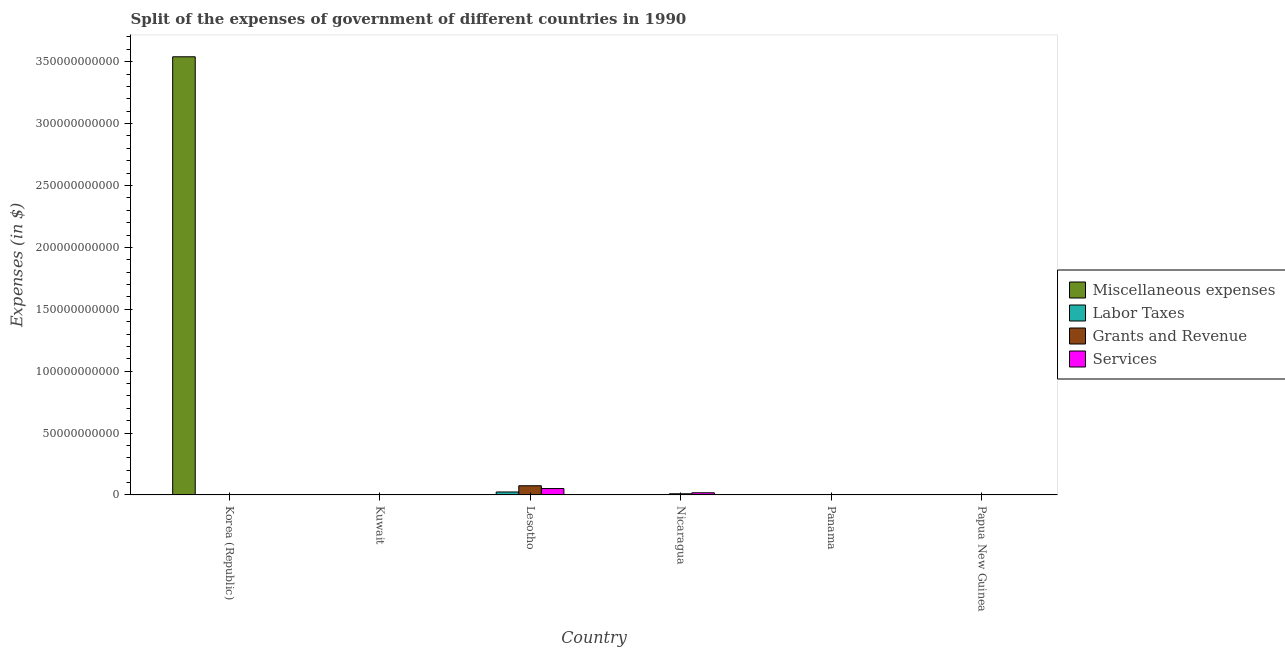How many different coloured bars are there?
Your answer should be compact. 4. How many groups of bars are there?
Your response must be concise. 6. Are the number of bars on each tick of the X-axis equal?
Offer a very short reply. Yes. How many bars are there on the 2nd tick from the left?
Offer a very short reply. 4. How many bars are there on the 2nd tick from the right?
Make the answer very short. 4. What is the label of the 3rd group of bars from the left?
Provide a short and direct response. Lesotho. What is the amount spent on labor taxes in Korea (Republic)?
Offer a terse response. 0.03. Across all countries, what is the maximum amount spent on miscellaneous expenses?
Provide a short and direct response. 3.54e+11. Across all countries, what is the minimum amount spent on miscellaneous expenses?
Your response must be concise. 6.90e+05. What is the total amount spent on miscellaneous expenses in the graph?
Keep it short and to the point. 3.54e+11. What is the difference between the amount spent on services in Lesotho and that in Panama?
Provide a short and direct response. 5.13e+09. What is the difference between the amount spent on labor taxes in Panama and the amount spent on services in Nicaragua?
Provide a succinct answer. -1.74e+09. What is the average amount spent on grants and revenue per country?
Make the answer very short. 1.42e+09. What is the difference between the amount spent on miscellaneous expenses and amount spent on grants and revenue in Kuwait?
Provide a succinct answer. 1.26e+08. What is the ratio of the amount spent on services in Korea (Republic) to that in Lesotho?
Your answer should be compact. 4.0704686289697906e-10. What is the difference between the highest and the second highest amount spent on services?
Your response must be concise. 3.42e+09. What is the difference between the highest and the lowest amount spent on services?
Your answer should be compact. 5.16e+09. Is the sum of the amount spent on grants and revenue in Nicaragua and Papua New Guinea greater than the maximum amount spent on labor taxes across all countries?
Give a very brief answer. No. What does the 3rd bar from the left in Lesotho represents?
Keep it short and to the point. Grants and Revenue. What does the 1st bar from the right in Korea (Republic) represents?
Provide a succinct answer. Services. Is it the case that in every country, the sum of the amount spent on miscellaneous expenses and amount spent on labor taxes is greater than the amount spent on grants and revenue?
Provide a short and direct response. No. Are the values on the major ticks of Y-axis written in scientific E-notation?
Ensure brevity in your answer.  No. Does the graph contain grids?
Give a very brief answer. No. Where does the legend appear in the graph?
Your answer should be very brief. Center right. What is the title of the graph?
Keep it short and to the point. Split of the expenses of government of different countries in 1990. What is the label or title of the X-axis?
Provide a short and direct response. Country. What is the label or title of the Y-axis?
Your answer should be compact. Expenses (in $). What is the Expenses (in $) of Miscellaneous expenses in Korea (Republic)?
Give a very brief answer. 3.54e+11. What is the Expenses (in $) in Labor Taxes in Korea (Republic)?
Keep it short and to the point. 0.03. What is the Expenses (in $) in Grants and Revenue in Korea (Republic)?
Keep it short and to the point. 0.63. What is the Expenses (in $) in Services in Korea (Republic)?
Provide a succinct answer. 2.1. What is the Expenses (in $) in Miscellaneous expenses in Kuwait?
Make the answer very short. 1.56e+08. What is the Expenses (in $) in Labor Taxes in Kuwait?
Provide a succinct answer. 2.10e+07. What is the Expenses (in $) of Grants and Revenue in Kuwait?
Your response must be concise. 3.00e+07. What is the Expenses (in $) in Services in Kuwait?
Ensure brevity in your answer.  4.20e+07. What is the Expenses (in $) of Miscellaneous expenses in Lesotho?
Offer a very short reply. 1.37e+07. What is the Expenses (in $) in Labor Taxes in Lesotho?
Provide a succinct answer. 2.39e+09. What is the Expenses (in $) of Grants and Revenue in Lesotho?
Offer a very short reply. 7.42e+09. What is the Expenses (in $) in Services in Lesotho?
Offer a terse response. 5.16e+09. What is the Expenses (in $) in Miscellaneous expenses in Nicaragua?
Your answer should be compact. 6.90e+05. What is the Expenses (in $) of Labor Taxes in Nicaragua?
Provide a short and direct response. 6.90e+07. What is the Expenses (in $) in Grants and Revenue in Nicaragua?
Make the answer very short. 9.19e+08. What is the Expenses (in $) in Services in Nicaragua?
Keep it short and to the point. 1.75e+09. What is the Expenses (in $) in Miscellaneous expenses in Panama?
Give a very brief answer. 8.40e+06. What is the Expenses (in $) in Labor Taxes in Panama?
Keep it short and to the point. 5.35e+06. What is the Expenses (in $) of Grants and Revenue in Panama?
Provide a short and direct response. 8.85e+07. What is the Expenses (in $) in Services in Panama?
Offer a very short reply. 3.87e+07. What is the Expenses (in $) of Miscellaneous expenses in Papua New Guinea?
Ensure brevity in your answer.  4.37e+06. What is the Expenses (in $) of Labor Taxes in Papua New Guinea?
Your response must be concise. 2.81e+06. What is the Expenses (in $) in Grants and Revenue in Papua New Guinea?
Keep it short and to the point. 9.55e+07. What is the Expenses (in $) of Services in Papua New Guinea?
Offer a terse response. 1.21e+08. Across all countries, what is the maximum Expenses (in $) of Miscellaneous expenses?
Give a very brief answer. 3.54e+11. Across all countries, what is the maximum Expenses (in $) in Labor Taxes?
Ensure brevity in your answer.  2.39e+09. Across all countries, what is the maximum Expenses (in $) of Grants and Revenue?
Make the answer very short. 7.42e+09. Across all countries, what is the maximum Expenses (in $) of Services?
Your response must be concise. 5.16e+09. Across all countries, what is the minimum Expenses (in $) in Miscellaneous expenses?
Provide a short and direct response. 6.90e+05. Across all countries, what is the minimum Expenses (in $) in Labor Taxes?
Provide a succinct answer. 0.03. Across all countries, what is the minimum Expenses (in $) of Grants and Revenue?
Provide a short and direct response. 0.63. Across all countries, what is the minimum Expenses (in $) of Services?
Offer a very short reply. 2.1. What is the total Expenses (in $) of Miscellaneous expenses in the graph?
Give a very brief answer. 3.54e+11. What is the total Expenses (in $) in Labor Taxes in the graph?
Provide a succinct answer. 2.49e+09. What is the total Expenses (in $) in Grants and Revenue in the graph?
Your response must be concise. 8.55e+09. What is the total Expenses (in $) of Services in the graph?
Make the answer very short. 7.11e+09. What is the difference between the Expenses (in $) of Miscellaneous expenses in Korea (Republic) and that in Kuwait?
Your response must be concise. 3.54e+11. What is the difference between the Expenses (in $) of Labor Taxes in Korea (Republic) and that in Kuwait?
Your answer should be very brief. -2.10e+07. What is the difference between the Expenses (in $) in Grants and Revenue in Korea (Republic) and that in Kuwait?
Ensure brevity in your answer.  -3.00e+07. What is the difference between the Expenses (in $) in Services in Korea (Republic) and that in Kuwait?
Offer a very short reply. -4.20e+07. What is the difference between the Expenses (in $) of Miscellaneous expenses in Korea (Republic) and that in Lesotho?
Your answer should be very brief. 3.54e+11. What is the difference between the Expenses (in $) of Labor Taxes in Korea (Republic) and that in Lesotho?
Your answer should be very brief. -2.39e+09. What is the difference between the Expenses (in $) of Grants and Revenue in Korea (Republic) and that in Lesotho?
Your answer should be very brief. -7.42e+09. What is the difference between the Expenses (in $) in Services in Korea (Republic) and that in Lesotho?
Your answer should be very brief. -5.16e+09. What is the difference between the Expenses (in $) of Miscellaneous expenses in Korea (Republic) and that in Nicaragua?
Keep it short and to the point. 3.54e+11. What is the difference between the Expenses (in $) of Labor Taxes in Korea (Republic) and that in Nicaragua?
Your answer should be very brief. -6.90e+07. What is the difference between the Expenses (in $) of Grants and Revenue in Korea (Republic) and that in Nicaragua?
Keep it short and to the point. -9.19e+08. What is the difference between the Expenses (in $) of Services in Korea (Republic) and that in Nicaragua?
Provide a succinct answer. -1.75e+09. What is the difference between the Expenses (in $) in Miscellaneous expenses in Korea (Republic) and that in Panama?
Your response must be concise. 3.54e+11. What is the difference between the Expenses (in $) of Labor Taxes in Korea (Republic) and that in Panama?
Provide a short and direct response. -5.35e+06. What is the difference between the Expenses (in $) of Grants and Revenue in Korea (Republic) and that in Panama?
Give a very brief answer. -8.85e+07. What is the difference between the Expenses (in $) in Services in Korea (Republic) and that in Panama?
Provide a succinct answer. -3.87e+07. What is the difference between the Expenses (in $) of Miscellaneous expenses in Korea (Republic) and that in Papua New Guinea?
Your answer should be compact. 3.54e+11. What is the difference between the Expenses (in $) in Labor Taxes in Korea (Republic) and that in Papua New Guinea?
Provide a short and direct response. -2.81e+06. What is the difference between the Expenses (in $) of Grants and Revenue in Korea (Republic) and that in Papua New Guinea?
Offer a very short reply. -9.55e+07. What is the difference between the Expenses (in $) in Services in Korea (Republic) and that in Papua New Guinea?
Ensure brevity in your answer.  -1.21e+08. What is the difference between the Expenses (in $) of Miscellaneous expenses in Kuwait and that in Lesotho?
Provide a short and direct response. 1.42e+08. What is the difference between the Expenses (in $) in Labor Taxes in Kuwait and that in Lesotho?
Make the answer very short. -2.37e+09. What is the difference between the Expenses (in $) in Grants and Revenue in Kuwait and that in Lesotho?
Ensure brevity in your answer.  -7.39e+09. What is the difference between the Expenses (in $) of Services in Kuwait and that in Lesotho?
Your answer should be compact. -5.12e+09. What is the difference between the Expenses (in $) in Miscellaneous expenses in Kuwait and that in Nicaragua?
Make the answer very short. 1.55e+08. What is the difference between the Expenses (in $) of Labor Taxes in Kuwait and that in Nicaragua?
Make the answer very short. -4.80e+07. What is the difference between the Expenses (in $) in Grants and Revenue in Kuwait and that in Nicaragua?
Your response must be concise. -8.89e+08. What is the difference between the Expenses (in $) of Services in Kuwait and that in Nicaragua?
Provide a succinct answer. -1.70e+09. What is the difference between the Expenses (in $) in Miscellaneous expenses in Kuwait and that in Panama?
Provide a short and direct response. 1.48e+08. What is the difference between the Expenses (in $) in Labor Taxes in Kuwait and that in Panama?
Your response must be concise. 1.56e+07. What is the difference between the Expenses (in $) of Grants and Revenue in Kuwait and that in Panama?
Make the answer very short. -5.85e+07. What is the difference between the Expenses (in $) of Services in Kuwait and that in Panama?
Offer a very short reply. 3.28e+06. What is the difference between the Expenses (in $) of Miscellaneous expenses in Kuwait and that in Papua New Guinea?
Your response must be concise. 1.52e+08. What is the difference between the Expenses (in $) of Labor Taxes in Kuwait and that in Papua New Guinea?
Offer a very short reply. 1.82e+07. What is the difference between the Expenses (in $) in Grants and Revenue in Kuwait and that in Papua New Guinea?
Make the answer very short. -6.55e+07. What is the difference between the Expenses (in $) in Services in Kuwait and that in Papua New Guinea?
Give a very brief answer. -7.94e+07. What is the difference between the Expenses (in $) in Miscellaneous expenses in Lesotho and that in Nicaragua?
Ensure brevity in your answer.  1.30e+07. What is the difference between the Expenses (in $) of Labor Taxes in Lesotho and that in Nicaragua?
Provide a succinct answer. 2.32e+09. What is the difference between the Expenses (in $) in Grants and Revenue in Lesotho and that in Nicaragua?
Your answer should be compact. 6.50e+09. What is the difference between the Expenses (in $) of Services in Lesotho and that in Nicaragua?
Offer a very short reply. 3.42e+09. What is the difference between the Expenses (in $) in Miscellaneous expenses in Lesotho and that in Panama?
Your answer should be compact. 5.30e+06. What is the difference between the Expenses (in $) in Labor Taxes in Lesotho and that in Panama?
Make the answer very short. 2.39e+09. What is the difference between the Expenses (in $) of Grants and Revenue in Lesotho and that in Panama?
Make the answer very short. 7.33e+09. What is the difference between the Expenses (in $) in Services in Lesotho and that in Panama?
Provide a succinct answer. 5.13e+09. What is the difference between the Expenses (in $) in Miscellaneous expenses in Lesotho and that in Papua New Guinea?
Provide a succinct answer. 9.33e+06. What is the difference between the Expenses (in $) of Labor Taxes in Lesotho and that in Papua New Guinea?
Your answer should be compact. 2.39e+09. What is the difference between the Expenses (in $) of Grants and Revenue in Lesotho and that in Papua New Guinea?
Provide a succinct answer. 7.32e+09. What is the difference between the Expenses (in $) of Services in Lesotho and that in Papua New Guinea?
Give a very brief answer. 5.04e+09. What is the difference between the Expenses (in $) in Miscellaneous expenses in Nicaragua and that in Panama?
Ensure brevity in your answer.  -7.71e+06. What is the difference between the Expenses (in $) in Labor Taxes in Nicaragua and that in Panama?
Give a very brief answer. 6.36e+07. What is the difference between the Expenses (in $) in Grants and Revenue in Nicaragua and that in Panama?
Your answer should be very brief. 8.31e+08. What is the difference between the Expenses (in $) of Services in Nicaragua and that in Panama?
Give a very brief answer. 1.71e+09. What is the difference between the Expenses (in $) of Miscellaneous expenses in Nicaragua and that in Papua New Guinea?
Offer a very short reply. -3.68e+06. What is the difference between the Expenses (in $) in Labor Taxes in Nicaragua and that in Papua New Guinea?
Offer a very short reply. 6.62e+07. What is the difference between the Expenses (in $) of Grants and Revenue in Nicaragua and that in Papua New Guinea?
Your response must be concise. 8.24e+08. What is the difference between the Expenses (in $) in Services in Nicaragua and that in Papua New Guinea?
Keep it short and to the point. 1.63e+09. What is the difference between the Expenses (in $) of Miscellaneous expenses in Panama and that in Papua New Guinea?
Provide a short and direct response. 4.03e+06. What is the difference between the Expenses (in $) of Labor Taxes in Panama and that in Papua New Guinea?
Your answer should be very brief. 2.54e+06. What is the difference between the Expenses (in $) of Grants and Revenue in Panama and that in Papua New Guinea?
Keep it short and to the point. -7.03e+06. What is the difference between the Expenses (in $) in Services in Panama and that in Papua New Guinea?
Provide a succinct answer. -8.27e+07. What is the difference between the Expenses (in $) of Miscellaneous expenses in Korea (Republic) and the Expenses (in $) of Labor Taxes in Kuwait?
Your response must be concise. 3.54e+11. What is the difference between the Expenses (in $) of Miscellaneous expenses in Korea (Republic) and the Expenses (in $) of Grants and Revenue in Kuwait?
Provide a succinct answer. 3.54e+11. What is the difference between the Expenses (in $) in Miscellaneous expenses in Korea (Republic) and the Expenses (in $) in Services in Kuwait?
Offer a very short reply. 3.54e+11. What is the difference between the Expenses (in $) of Labor Taxes in Korea (Republic) and the Expenses (in $) of Grants and Revenue in Kuwait?
Provide a succinct answer. -3.00e+07. What is the difference between the Expenses (in $) of Labor Taxes in Korea (Republic) and the Expenses (in $) of Services in Kuwait?
Your response must be concise. -4.20e+07. What is the difference between the Expenses (in $) of Grants and Revenue in Korea (Republic) and the Expenses (in $) of Services in Kuwait?
Your response must be concise. -4.20e+07. What is the difference between the Expenses (in $) of Miscellaneous expenses in Korea (Republic) and the Expenses (in $) of Labor Taxes in Lesotho?
Your response must be concise. 3.52e+11. What is the difference between the Expenses (in $) of Miscellaneous expenses in Korea (Republic) and the Expenses (in $) of Grants and Revenue in Lesotho?
Keep it short and to the point. 3.47e+11. What is the difference between the Expenses (in $) in Miscellaneous expenses in Korea (Republic) and the Expenses (in $) in Services in Lesotho?
Offer a terse response. 3.49e+11. What is the difference between the Expenses (in $) of Labor Taxes in Korea (Republic) and the Expenses (in $) of Grants and Revenue in Lesotho?
Your response must be concise. -7.42e+09. What is the difference between the Expenses (in $) of Labor Taxes in Korea (Republic) and the Expenses (in $) of Services in Lesotho?
Offer a terse response. -5.16e+09. What is the difference between the Expenses (in $) of Grants and Revenue in Korea (Republic) and the Expenses (in $) of Services in Lesotho?
Keep it short and to the point. -5.16e+09. What is the difference between the Expenses (in $) in Miscellaneous expenses in Korea (Republic) and the Expenses (in $) in Labor Taxes in Nicaragua?
Your response must be concise. 3.54e+11. What is the difference between the Expenses (in $) of Miscellaneous expenses in Korea (Republic) and the Expenses (in $) of Grants and Revenue in Nicaragua?
Your response must be concise. 3.53e+11. What is the difference between the Expenses (in $) of Miscellaneous expenses in Korea (Republic) and the Expenses (in $) of Services in Nicaragua?
Your answer should be compact. 3.52e+11. What is the difference between the Expenses (in $) of Labor Taxes in Korea (Republic) and the Expenses (in $) of Grants and Revenue in Nicaragua?
Give a very brief answer. -9.19e+08. What is the difference between the Expenses (in $) of Labor Taxes in Korea (Republic) and the Expenses (in $) of Services in Nicaragua?
Provide a succinct answer. -1.75e+09. What is the difference between the Expenses (in $) in Grants and Revenue in Korea (Republic) and the Expenses (in $) in Services in Nicaragua?
Provide a short and direct response. -1.75e+09. What is the difference between the Expenses (in $) in Miscellaneous expenses in Korea (Republic) and the Expenses (in $) in Labor Taxes in Panama?
Your answer should be compact. 3.54e+11. What is the difference between the Expenses (in $) of Miscellaneous expenses in Korea (Republic) and the Expenses (in $) of Grants and Revenue in Panama?
Your answer should be compact. 3.54e+11. What is the difference between the Expenses (in $) in Miscellaneous expenses in Korea (Republic) and the Expenses (in $) in Services in Panama?
Offer a very short reply. 3.54e+11. What is the difference between the Expenses (in $) in Labor Taxes in Korea (Republic) and the Expenses (in $) in Grants and Revenue in Panama?
Your response must be concise. -8.85e+07. What is the difference between the Expenses (in $) in Labor Taxes in Korea (Republic) and the Expenses (in $) in Services in Panama?
Ensure brevity in your answer.  -3.87e+07. What is the difference between the Expenses (in $) of Grants and Revenue in Korea (Republic) and the Expenses (in $) of Services in Panama?
Your response must be concise. -3.87e+07. What is the difference between the Expenses (in $) of Miscellaneous expenses in Korea (Republic) and the Expenses (in $) of Labor Taxes in Papua New Guinea?
Your answer should be compact. 3.54e+11. What is the difference between the Expenses (in $) of Miscellaneous expenses in Korea (Republic) and the Expenses (in $) of Grants and Revenue in Papua New Guinea?
Make the answer very short. 3.54e+11. What is the difference between the Expenses (in $) of Miscellaneous expenses in Korea (Republic) and the Expenses (in $) of Services in Papua New Guinea?
Ensure brevity in your answer.  3.54e+11. What is the difference between the Expenses (in $) in Labor Taxes in Korea (Republic) and the Expenses (in $) in Grants and Revenue in Papua New Guinea?
Offer a terse response. -9.55e+07. What is the difference between the Expenses (in $) in Labor Taxes in Korea (Republic) and the Expenses (in $) in Services in Papua New Guinea?
Offer a terse response. -1.21e+08. What is the difference between the Expenses (in $) in Grants and Revenue in Korea (Republic) and the Expenses (in $) in Services in Papua New Guinea?
Ensure brevity in your answer.  -1.21e+08. What is the difference between the Expenses (in $) in Miscellaneous expenses in Kuwait and the Expenses (in $) in Labor Taxes in Lesotho?
Your answer should be very brief. -2.24e+09. What is the difference between the Expenses (in $) in Miscellaneous expenses in Kuwait and the Expenses (in $) in Grants and Revenue in Lesotho?
Your answer should be compact. -7.26e+09. What is the difference between the Expenses (in $) in Miscellaneous expenses in Kuwait and the Expenses (in $) in Services in Lesotho?
Your answer should be very brief. -5.01e+09. What is the difference between the Expenses (in $) of Labor Taxes in Kuwait and the Expenses (in $) of Grants and Revenue in Lesotho?
Your answer should be compact. -7.40e+09. What is the difference between the Expenses (in $) in Labor Taxes in Kuwait and the Expenses (in $) in Services in Lesotho?
Offer a terse response. -5.14e+09. What is the difference between the Expenses (in $) of Grants and Revenue in Kuwait and the Expenses (in $) of Services in Lesotho?
Your answer should be very brief. -5.13e+09. What is the difference between the Expenses (in $) of Miscellaneous expenses in Kuwait and the Expenses (in $) of Labor Taxes in Nicaragua?
Ensure brevity in your answer.  8.70e+07. What is the difference between the Expenses (in $) of Miscellaneous expenses in Kuwait and the Expenses (in $) of Grants and Revenue in Nicaragua?
Provide a succinct answer. -7.63e+08. What is the difference between the Expenses (in $) in Miscellaneous expenses in Kuwait and the Expenses (in $) in Services in Nicaragua?
Offer a very short reply. -1.59e+09. What is the difference between the Expenses (in $) of Labor Taxes in Kuwait and the Expenses (in $) of Grants and Revenue in Nicaragua?
Your response must be concise. -8.98e+08. What is the difference between the Expenses (in $) of Labor Taxes in Kuwait and the Expenses (in $) of Services in Nicaragua?
Offer a terse response. -1.73e+09. What is the difference between the Expenses (in $) in Grants and Revenue in Kuwait and the Expenses (in $) in Services in Nicaragua?
Your answer should be compact. -1.72e+09. What is the difference between the Expenses (in $) of Miscellaneous expenses in Kuwait and the Expenses (in $) of Labor Taxes in Panama?
Offer a very short reply. 1.51e+08. What is the difference between the Expenses (in $) in Miscellaneous expenses in Kuwait and the Expenses (in $) in Grants and Revenue in Panama?
Provide a short and direct response. 6.75e+07. What is the difference between the Expenses (in $) of Miscellaneous expenses in Kuwait and the Expenses (in $) of Services in Panama?
Your answer should be very brief. 1.17e+08. What is the difference between the Expenses (in $) of Labor Taxes in Kuwait and the Expenses (in $) of Grants and Revenue in Panama?
Make the answer very short. -6.75e+07. What is the difference between the Expenses (in $) in Labor Taxes in Kuwait and the Expenses (in $) in Services in Panama?
Your answer should be very brief. -1.77e+07. What is the difference between the Expenses (in $) in Grants and Revenue in Kuwait and the Expenses (in $) in Services in Panama?
Keep it short and to the point. -8.72e+06. What is the difference between the Expenses (in $) in Miscellaneous expenses in Kuwait and the Expenses (in $) in Labor Taxes in Papua New Guinea?
Provide a short and direct response. 1.53e+08. What is the difference between the Expenses (in $) of Miscellaneous expenses in Kuwait and the Expenses (in $) of Grants and Revenue in Papua New Guinea?
Keep it short and to the point. 6.05e+07. What is the difference between the Expenses (in $) in Miscellaneous expenses in Kuwait and the Expenses (in $) in Services in Papua New Guinea?
Your response must be concise. 3.46e+07. What is the difference between the Expenses (in $) in Labor Taxes in Kuwait and the Expenses (in $) in Grants and Revenue in Papua New Guinea?
Keep it short and to the point. -7.45e+07. What is the difference between the Expenses (in $) of Labor Taxes in Kuwait and the Expenses (in $) of Services in Papua New Guinea?
Offer a terse response. -1.00e+08. What is the difference between the Expenses (in $) in Grants and Revenue in Kuwait and the Expenses (in $) in Services in Papua New Guinea?
Provide a succinct answer. -9.14e+07. What is the difference between the Expenses (in $) in Miscellaneous expenses in Lesotho and the Expenses (in $) in Labor Taxes in Nicaragua?
Provide a succinct answer. -5.53e+07. What is the difference between the Expenses (in $) in Miscellaneous expenses in Lesotho and the Expenses (in $) in Grants and Revenue in Nicaragua?
Make the answer very short. -9.06e+08. What is the difference between the Expenses (in $) of Miscellaneous expenses in Lesotho and the Expenses (in $) of Services in Nicaragua?
Make the answer very short. -1.73e+09. What is the difference between the Expenses (in $) in Labor Taxes in Lesotho and the Expenses (in $) in Grants and Revenue in Nicaragua?
Your response must be concise. 1.47e+09. What is the difference between the Expenses (in $) in Labor Taxes in Lesotho and the Expenses (in $) in Services in Nicaragua?
Offer a terse response. 6.44e+08. What is the difference between the Expenses (in $) of Grants and Revenue in Lesotho and the Expenses (in $) of Services in Nicaragua?
Offer a terse response. 5.67e+09. What is the difference between the Expenses (in $) in Miscellaneous expenses in Lesotho and the Expenses (in $) in Labor Taxes in Panama?
Offer a terse response. 8.35e+06. What is the difference between the Expenses (in $) of Miscellaneous expenses in Lesotho and the Expenses (in $) of Grants and Revenue in Panama?
Your response must be concise. -7.48e+07. What is the difference between the Expenses (in $) of Miscellaneous expenses in Lesotho and the Expenses (in $) of Services in Panama?
Your answer should be very brief. -2.50e+07. What is the difference between the Expenses (in $) in Labor Taxes in Lesotho and the Expenses (in $) in Grants and Revenue in Panama?
Give a very brief answer. 2.30e+09. What is the difference between the Expenses (in $) in Labor Taxes in Lesotho and the Expenses (in $) in Services in Panama?
Give a very brief answer. 2.35e+09. What is the difference between the Expenses (in $) in Grants and Revenue in Lesotho and the Expenses (in $) in Services in Panama?
Your answer should be compact. 7.38e+09. What is the difference between the Expenses (in $) in Miscellaneous expenses in Lesotho and the Expenses (in $) in Labor Taxes in Papua New Guinea?
Make the answer very short. 1.09e+07. What is the difference between the Expenses (in $) of Miscellaneous expenses in Lesotho and the Expenses (in $) of Grants and Revenue in Papua New Guinea?
Offer a terse response. -8.18e+07. What is the difference between the Expenses (in $) in Miscellaneous expenses in Lesotho and the Expenses (in $) in Services in Papua New Guinea?
Your response must be concise. -1.08e+08. What is the difference between the Expenses (in $) of Labor Taxes in Lesotho and the Expenses (in $) of Grants and Revenue in Papua New Guinea?
Make the answer very short. 2.30e+09. What is the difference between the Expenses (in $) in Labor Taxes in Lesotho and the Expenses (in $) in Services in Papua New Guinea?
Provide a succinct answer. 2.27e+09. What is the difference between the Expenses (in $) of Grants and Revenue in Lesotho and the Expenses (in $) of Services in Papua New Guinea?
Provide a short and direct response. 7.29e+09. What is the difference between the Expenses (in $) of Miscellaneous expenses in Nicaragua and the Expenses (in $) of Labor Taxes in Panama?
Your answer should be compact. -4.66e+06. What is the difference between the Expenses (in $) in Miscellaneous expenses in Nicaragua and the Expenses (in $) in Grants and Revenue in Panama?
Offer a very short reply. -8.78e+07. What is the difference between the Expenses (in $) of Miscellaneous expenses in Nicaragua and the Expenses (in $) of Services in Panama?
Your answer should be very brief. -3.80e+07. What is the difference between the Expenses (in $) in Labor Taxes in Nicaragua and the Expenses (in $) in Grants and Revenue in Panama?
Your response must be concise. -1.95e+07. What is the difference between the Expenses (in $) in Labor Taxes in Nicaragua and the Expenses (in $) in Services in Panama?
Keep it short and to the point. 3.03e+07. What is the difference between the Expenses (in $) in Grants and Revenue in Nicaragua and the Expenses (in $) in Services in Panama?
Ensure brevity in your answer.  8.81e+08. What is the difference between the Expenses (in $) in Miscellaneous expenses in Nicaragua and the Expenses (in $) in Labor Taxes in Papua New Guinea?
Keep it short and to the point. -2.12e+06. What is the difference between the Expenses (in $) in Miscellaneous expenses in Nicaragua and the Expenses (in $) in Grants and Revenue in Papua New Guinea?
Your answer should be very brief. -9.48e+07. What is the difference between the Expenses (in $) in Miscellaneous expenses in Nicaragua and the Expenses (in $) in Services in Papua New Guinea?
Your answer should be compact. -1.21e+08. What is the difference between the Expenses (in $) of Labor Taxes in Nicaragua and the Expenses (in $) of Grants and Revenue in Papua New Guinea?
Ensure brevity in your answer.  -2.65e+07. What is the difference between the Expenses (in $) in Labor Taxes in Nicaragua and the Expenses (in $) in Services in Papua New Guinea?
Provide a short and direct response. -5.24e+07. What is the difference between the Expenses (in $) in Grants and Revenue in Nicaragua and the Expenses (in $) in Services in Papua New Guinea?
Ensure brevity in your answer.  7.98e+08. What is the difference between the Expenses (in $) of Miscellaneous expenses in Panama and the Expenses (in $) of Labor Taxes in Papua New Guinea?
Keep it short and to the point. 5.59e+06. What is the difference between the Expenses (in $) in Miscellaneous expenses in Panama and the Expenses (in $) in Grants and Revenue in Papua New Guinea?
Give a very brief answer. -8.71e+07. What is the difference between the Expenses (in $) in Miscellaneous expenses in Panama and the Expenses (in $) in Services in Papua New Guinea?
Your response must be concise. -1.13e+08. What is the difference between the Expenses (in $) in Labor Taxes in Panama and the Expenses (in $) in Grants and Revenue in Papua New Guinea?
Your response must be concise. -9.02e+07. What is the difference between the Expenses (in $) of Labor Taxes in Panama and the Expenses (in $) of Services in Papua New Guinea?
Make the answer very short. -1.16e+08. What is the difference between the Expenses (in $) of Grants and Revenue in Panama and the Expenses (in $) of Services in Papua New Guinea?
Offer a terse response. -3.29e+07. What is the average Expenses (in $) of Miscellaneous expenses per country?
Provide a short and direct response. 5.90e+1. What is the average Expenses (in $) in Labor Taxes per country?
Offer a very short reply. 4.15e+08. What is the average Expenses (in $) in Grants and Revenue per country?
Give a very brief answer. 1.42e+09. What is the average Expenses (in $) of Services per country?
Make the answer very short. 1.19e+09. What is the difference between the Expenses (in $) of Miscellaneous expenses and Expenses (in $) of Labor Taxes in Korea (Republic)?
Offer a very short reply. 3.54e+11. What is the difference between the Expenses (in $) of Miscellaneous expenses and Expenses (in $) of Grants and Revenue in Korea (Republic)?
Ensure brevity in your answer.  3.54e+11. What is the difference between the Expenses (in $) of Miscellaneous expenses and Expenses (in $) of Services in Korea (Republic)?
Your answer should be compact. 3.54e+11. What is the difference between the Expenses (in $) of Labor Taxes and Expenses (in $) of Grants and Revenue in Korea (Republic)?
Your answer should be compact. -0.6. What is the difference between the Expenses (in $) in Labor Taxes and Expenses (in $) in Services in Korea (Republic)?
Offer a terse response. -2.07. What is the difference between the Expenses (in $) in Grants and Revenue and Expenses (in $) in Services in Korea (Republic)?
Your answer should be compact. -1.47. What is the difference between the Expenses (in $) of Miscellaneous expenses and Expenses (in $) of Labor Taxes in Kuwait?
Provide a succinct answer. 1.35e+08. What is the difference between the Expenses (in $) of Miscellaneous expenses and Expenses (in $) of Grants and Revenue in Kuwait?
Your answer should be compact. 1.26e+08. What is the difference between the Expenses (in $) of Miscellaneous expenses and Expenses (in $) of Services in Kuwait?
Provide a succinct answer. 1.14e+08. What is the difference between the Expenses (in $) of Labor Taxes and Expenses (in $) of Grants and Revenue in Kuwait?
Make the answer very short. -9.00e+06. What is the difference between the Expenses (in $) of Labor Taxes and Expenses (in $) of Services in Kuwait?
Your answer should be compact. -2.10e+07. What is the difference between the Expenses (in $) of Grants and Revenue and Expenses (in $) of Services in Kuwait?
Your response must be concise. -1.20e+07. What is the difference between the Expenses (in $) in Miscellaneous expenses and Expenses (in $) in Labor Taxes in Lesotho?
Your answer should be compact. -2.38e+09. What is the difference between the Expenses (in $) in Miscellaneous expenses and Expenses (in $) in Grants and Revenue in Lesotho?
Provide a short and direct response. -7.40e+09. What is the difference between the Expenses (in $) of Miscellaneous expenses and Expenses (in $) of Services in Lesotho?
Keep it short and to the point. -5.15e+09. What is the difference between the Expenses (in $) of Labor Taxes and Expenses (in $) of Grants and Revenue in Lesotho?
Your answer should be very brief. -5.02e+09. What is the difference between the Expenses (in $) in Labor Taxes and Expenses (in $) in Services in Lesotho?
Make the answer very short. -2.77e+09. What is the difference between the Expenses (in $) of Grants and Revenue and Expenses (in $) of Services in Lesotho?
Your answer should be very brief. 2.25e+09. What is the difference between the Expenses (in $) of Miscellaneous expenses and Expenses (in $) of Labor Taxes in Nicaragua?
Give a very brief answer. -6.83e+07. What is the difference between the Expenses (in $) of Miscellaneous expenses and Expenses (in $) of Grants and Revenue in Nicaragua?
Your answer should be compact. -9.19e+08. What is the difference between the Expenses (in $) in Miscellaneous expenses and Expenses (in $) in Services in Nicaragua?
Your answer should be compact. -1.75e+09. What is the difference between the Expenses (in $) in Labor Taxes and Expenses (in $) in Grants and Revenue in Nicaragua?
Provide a succinct answer. -8.50e+08. What is the difference between the Expenses (in $) of Labor Taxes and Expenses (in $) of Services in Nicaragua?
Ensure brevity in your answer.  -1.68e+09. What is the difference between the Expenses (in $) in Grants and Revenue and Expenses (in $) in Services in Nicaragua?
Your answer should be very brief. -8.27e+08. What is the difference between the Expenses (in $) of Miscellaneous expenses and Expenses (in $) of Labor Taxes in Panama?
Offer a very short reply. 3.05e+06. What is the difference between the Expenses (in $) of Miscellaneous expenses and Expenses (in $) of Grants and Revenue in Panama?
Make the answer very short. -8.01e+07. What is the difference between the Expenses (in $) of Miscellaneous expenses and Expenses (in $) of Services in Panama?
Provide a short and direct response. -3.03e+07. What is the difference between the Expenses (in $) of Labor Taxes and Expenses (in $) of Grants and Revenue in Panama?
Offer a very short reply. -8.31e+07. What is the difference between the Expenses (in $) in Labor Taxes and Expenses (in $) in Services in Panama?
Your answer should be compact. -3.34e+07. What is the difference between the Expenses (in $) of Grants and Revenue and Expenses (in $) of Services in Panama?
Make the answer very short. 4.98e+07. What is the difference between the Expenses (in $) in Miscellaneous expenses and Expenses (in $) in Labor Taxes in Papua New Guinea?
Provide a succinct answer. 1.56e+06. What is the difference between the Expenses (in $) of Miscellaneous expenses and Expenses (in $) of Grants and Revenue in Papua New Guinea?
Your answer should be compact. -9.11e+07. What is the difference between the Expenses (in $) of Miscellaneous expenses and Expenses (in $) of Services in Papua New Guinea?
Your answer should be very brief. -1.17e+08. What is the difference between the Expenses (in $) of Labor Taxes and Expenses (in $) of Grants and Revenue in Papua New Guinea?
Give a very brief answer. -9.27e+07. What is the difference between the Expenses (in $) in Labor Taxes and Expenses (in $) in Services in Papua New Guinea?
Provide a short and direct response. -1.19e+08. What is the difference between the Expenses (in $) of Grants and Revenue and Expenses (in $) of Services in Papua New Guinea?
Your answer should be compact. -2.59e+07. What is the ratio of the Expenses (in $) of Miscellaneous expenses in Korea (Republic) to that in Kuwait?
Your answer should be compact. 2269.23. What is the ratio of the Expenses (in $) of Grants and Revenue in Korea (Republic) to that in Kuwait?
Offer a terse response. 0. What is the ratio of the Expenses (in $) of Services in Korea (Republic) to that in Kuwait?
Offer a terse response. 0. What is the ratio of the Expenses (in $) of Miscellaneous expenses in Korea (Republic) to that in Lesotho?
Your answer should be compact. 2.58e+04. What is the ratio of the Expenses (in $) in Labor Taxes in Korea (Republic) to that in Lesotho?
Your response must be concise. 0. What is the ratio of the Expenses (in $) in Miscellaneous expenses in Korea (Republic) to that in Nicaragua?
Make the answer very short. 5.13e+05. What is the ratio of the Expenses (in $) in Services in Korea (Republic) to that in Nicaragua?
Offer a very short reply. 0. What is the ratio of the Expenses (in $) in Miscellaneous expenses in Korea (Republic) to that in Panama?
Make the answer very short. 4.21e+04. What is the ratio of the Expenses (in $) of Grants and Revenue in Korea (Republic) to that in Panama?
Ensure brevity in your answer.  0. What is the ratio of the Expenses (in $) in Services in Korea (Republic) to that in Panama?
Ensure brevity in your answer.  0. What is the ratio of the Expenses (in $) in Miscellaneous expenses in Korea (Republic) to that in Papua New Guinea?
Keep it short and to the point. 8.10e+04. What is the ratio of the Expenses (in $) of Labor Taxes in Korea (Republic) to that in Papua New Guinea?
Offer a terse response. 0. What is the ratio of the Expenses (in $) of Grants and Revenue in Korea (Republic) to that in Papua New Guinea?
Ensure brevity in your answer.  0. What is the ratio of the Expenses (in $) in Miscellaneous expenses in Kuwait to that in Lesotho?
Your answer should be very brief. 11.39. What is the ratio of the Expenses (in $) of Labor Taxes in Kuwait to that in Lesotho?
Provide a succinct answer. 0.01. What is the ratio of the Expenses (in $) in Grants and Revenue in Kuwait to that in Lesotho?
Your answer should be compact. 0. What is the ratio of the Expenses (in $) of Services in Kuwait to that in Lesotho?
Ensure brevity in your answer.  0.01. What is the ratio of the Expenses (in $) of Miscellaneous expenses in Kuwait to that in Nicaragua?
Provide a succinct answer. 226.09. What is the ratio of the Expenses (in $) in Labor Taxes in Kuwait to that in Nicaragua?
Provide a short and direct response. 0.3. What is the ratio of the Expenses (in $) in Grants and Revenue in Kuwait to that in Nicaragua?
Ensure brevity in your answer.  0.03. What is the ratio of the Expenses (in $) of Services in Kuwait to that in Nicaragua?
Keep it short and to the point. 0.02. What is the ratio of the Expenses (in $) of Miscellaneous expenses in Kuwait to that in Panama?
Keep it short and to the point. 18.57. What is the ratio of the Expenses (in $) in Labor Taxes in Kuwait to that in Panama?
Keep it short and to the point. 3.93. What is the ratio of the Expenses (in $) of Grants and Revenue in Kuwait to that in Panama?
Provide a succinct answer. 0.34. What is the ratio of the Expenses (in $) of Services in Kuwait to that in Panama?
Your answer should be compact. 1.08. What is the ratio of the Expenses (in $) of Miscellaneous expenses in Kuwait to that in Papua New Guinea?
Provide a short and direct response. 35.7. What is the ratio of the Expenses (in $) in Labor Taxes in Kuwait to that in Papua New Guinea?
Your answer should be compact. 7.47. What is the ratio of the Expenses (in $) in Grants and Revenue in Kuwait to that in Papua New Guinea?
Provide a short and direct response. 0.31. What is the ratio of the Expenses (in $) in Services in Kuwait to that in Papua New Guinea?
Make the answer very short. 0.35. What is the ratio of the Expenses (in $) in Miscellaneous expenses in Lesotho to that in Nicaragua?
Provide a short and direct response. 19.86. What is the ratio of the Expenses (in $) of Labor Taxes in Lesotho to that in Nicaragua?
Provide a short and direct response. 34.65. What is the ratio of the Expenses (in $) in Grants and Revenue in Lesotho to that in Nicaragua?
Give a very brief answer. 8.07. What is the ratio of the Expenses (in $) in Services in Lesotho to that in Nicaragua?
Provide a succinct answer. 2.96. What is the ratio of the Expenses (in $) in Miscellaneous expenses in Lesotho to that in Panama?
Your response must be concise. 1.63. What is the ratio of the Expenses (in $) in Labor Taxes in Lesotho to that in Panama?
Make the answer very short. 446.92. What is the ratio of the Expenses (in $) in Grants and Revenue in Lesotho to that in Panama?
Make the answer very short. 83.83. What is the ratio of the Expenses (in $) of Services in Lesotho to that in Panama?
Offer a very short reply. 133.37. What is the ratio of the Expenses (in $) of Miscellaneous expenses in Lesotho to that in Papua New Guinea?
Your response must be concise. 3.13. What is the ratio of the Expenses (in $) of Labor Taxes in Lesotho to that in Papua New Guinea?
Keep it short and to the point. 850.89. What is the ratio of the Expenses (in $) in Grants and Revenue in Lesotho to that in Papua New Guinea?
Keep it short and to the point. 77.65. What is the ratio of the Expenses (in $) in Services in Lesotho to that in Papua New Guinea?
Your response must be concise. 42.53. What is the ratio of the Expenses (in $) in Miscellaneous expenses in Nicaragua to that in Panama?
Keep it short and to the point. 0.08. What is the ratio of the Expenses (in $) in Labor Taxes in Nicaragua to that in Panama?
Ensure brevity in your answer.  12.9. What is the ratio of the Expenses (in $) of Grants and Revenue in Nicaragua to that in Panama?
Give a very brief answer. 10.39. What is the ratio of the Expenses (in $) in Services in Nicaragua to that in Panama?
Offer a terse response. 45.11. What is the ratio of the Expenses (in $) of Miscellaneous expenses in Nicaragua to that in Papua New Guinea?
Provide a succinct answer. 0.16. What is the ratio of the Expenses (in $) of Labor Taxes in Nicaragua to that in Papua New Guinea?
Offer a very short reply. 24.56. What is the ratio of the Expenses (in $) of Grants and Revenue in Nicaragua to that in Papua New Guinea?
Provide a short and direct response. 9.63. What is the ratio of the Expenses (in $) of Services in Nicaragua to that in Papua New Guinea?
Make the answer very short. 14.39. What is the ratio of the Expenses (in $) in Miscellaneous expenses in Panama to that in Papua New Guinea?
Make the answer very short. 1.92. What is the ratio of the Expenses (in $) of Labor Taxes in Panama to that in Papua New Guinea?
Make the answer very short. 1.9. What is the ratio of the Expenses (in $) of Grants and Revenue in Panama to that in Papua New Guinea?
Your response must be concise. 0.93. What is the ratio of the Expenses (in $) of Services in Panama to that in Papua New Guinea?
Provide a succinct answer. 0.32. What is the difference between the highest and the second highest Expenses (in $) of Miscellaneous expenses?
Offer a terse response. 3.54e+11. What is the difference between the highest and the second highest Expenses (in $) in Labor Taxes?
Your answer should be very brief. 2.32e+09. What is the difference between the highest and the second highest Expenses (in $) in Grants and Revenue?
Provide a short and direct response. 6.50e+09. What is the difference between the highest and the second highest Expenses (in $) in Services?
Keep it short and to the point. 3.42e+09. What is the difference between the highest and the lowest Expenses (in $) in Miscellaneous expenses?
Your response must be concise. 3.54e+11. What is the difference between the highest and the lowest Expenses (in $) of Labor Taxes?
Offer a very short reply. 2.39e+09. What is the difference between the highest and the lowest Expenses (in $) of Grants and Revenue?
Provide a short and direct response. 7.42e+09. What is the difference between the highest and the lowest Expenses (in $) in Services?
Keep it short and to the point. 5.16e+09. 